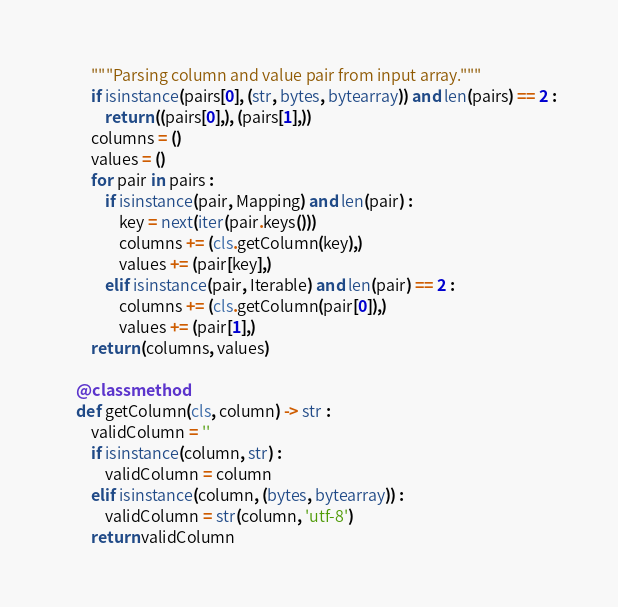Convert code to text. <code><loc_0><loc_0><loc_500><loc_500><_Python_>        """Parsing column and value pair from input array."""
        if isinstance(pairs[0], (str, bytes, bytearray)) and len(pairs) == 2 :
            return ((pairs[0],), (pairs[1],))
        columns = ()
        values = ()
        for pair in pairs :
            if isinstance(pair, Mapping) and len(pair) :
                key = next(iter(pair.keys()))
                columns += (cls.getColumn(key),)
                values += (pair[key],)
            elif isinstance(pair, Iterable) and len(pair) == 2 :
                columns += (cls.getColumn(pair[0]),)
                values += (pair[1],)
        return (columns, values)

    @classmethod
    def getColumn(cls, column) -> str :
        validColumn = ''
        if isinstance(column, str) :
            validColumn = column
        elif isinstance(column, (bytes, bytearray)) :
            validColumn = str(column, 'utf-8')
        return validColumn
</code> 